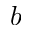<formula> <loc_0><loc_0><loc_500><loc_500>b</formula> 